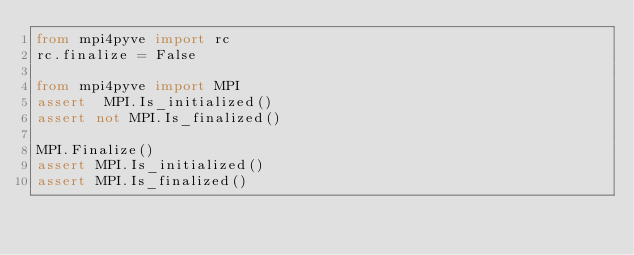<code> <loc_0><loc_0><loc_500><loc_500><_Python_>from mpi4pyve import rc
rc.finalize = False

from mpi4pyve import MPI
assert  MPI.Is_initialized()
assert not MPI.Is_finalized()

MPI.Finalize()
assert MPI.Is_initialized()
assert MPI.Is_finalized()
</code> 